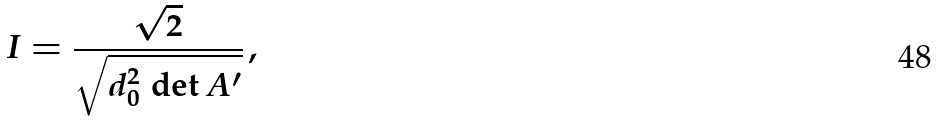Convert formula to latex. <formula><loc_0><loc_0><loc_500><loc_500>I = \frac { \sqrt { 2 } } { \sqrt { d _ { 0 } ^ { 2 } \, \det A ^ { \prime } } } \, ,</formula> 